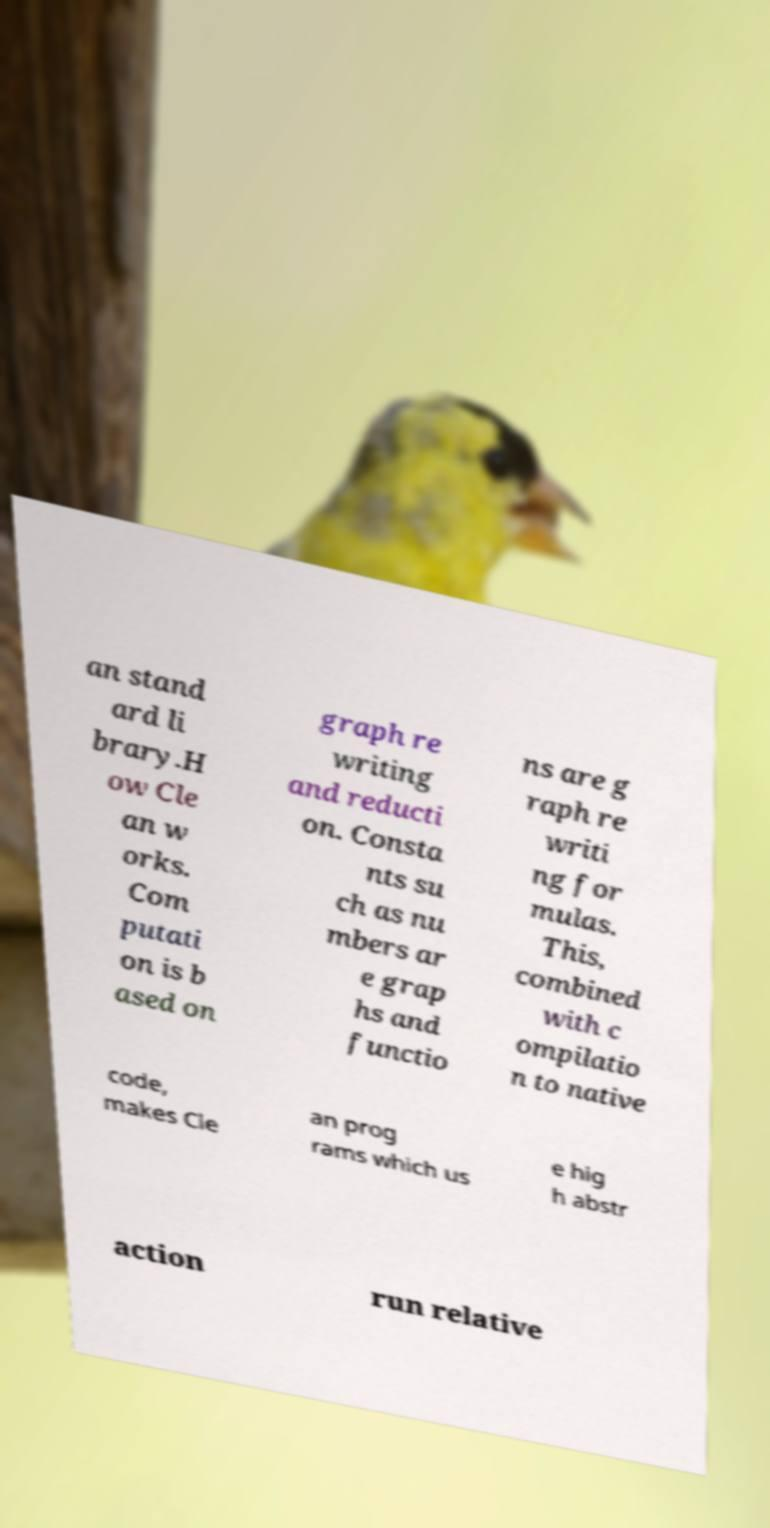Could you extract and type out the text from this image? an stand ard li brary.H ow Cle an w orks. Com putati on is b ased on graph re writing and reducti on. Consta nts su ch as nu mbers ar e grap hs and functio ns are g raph re writi ng for mulas. This, combined with c ompilatio n to native code, makes Cle an prog rams which us e hig h abstr action run relative 